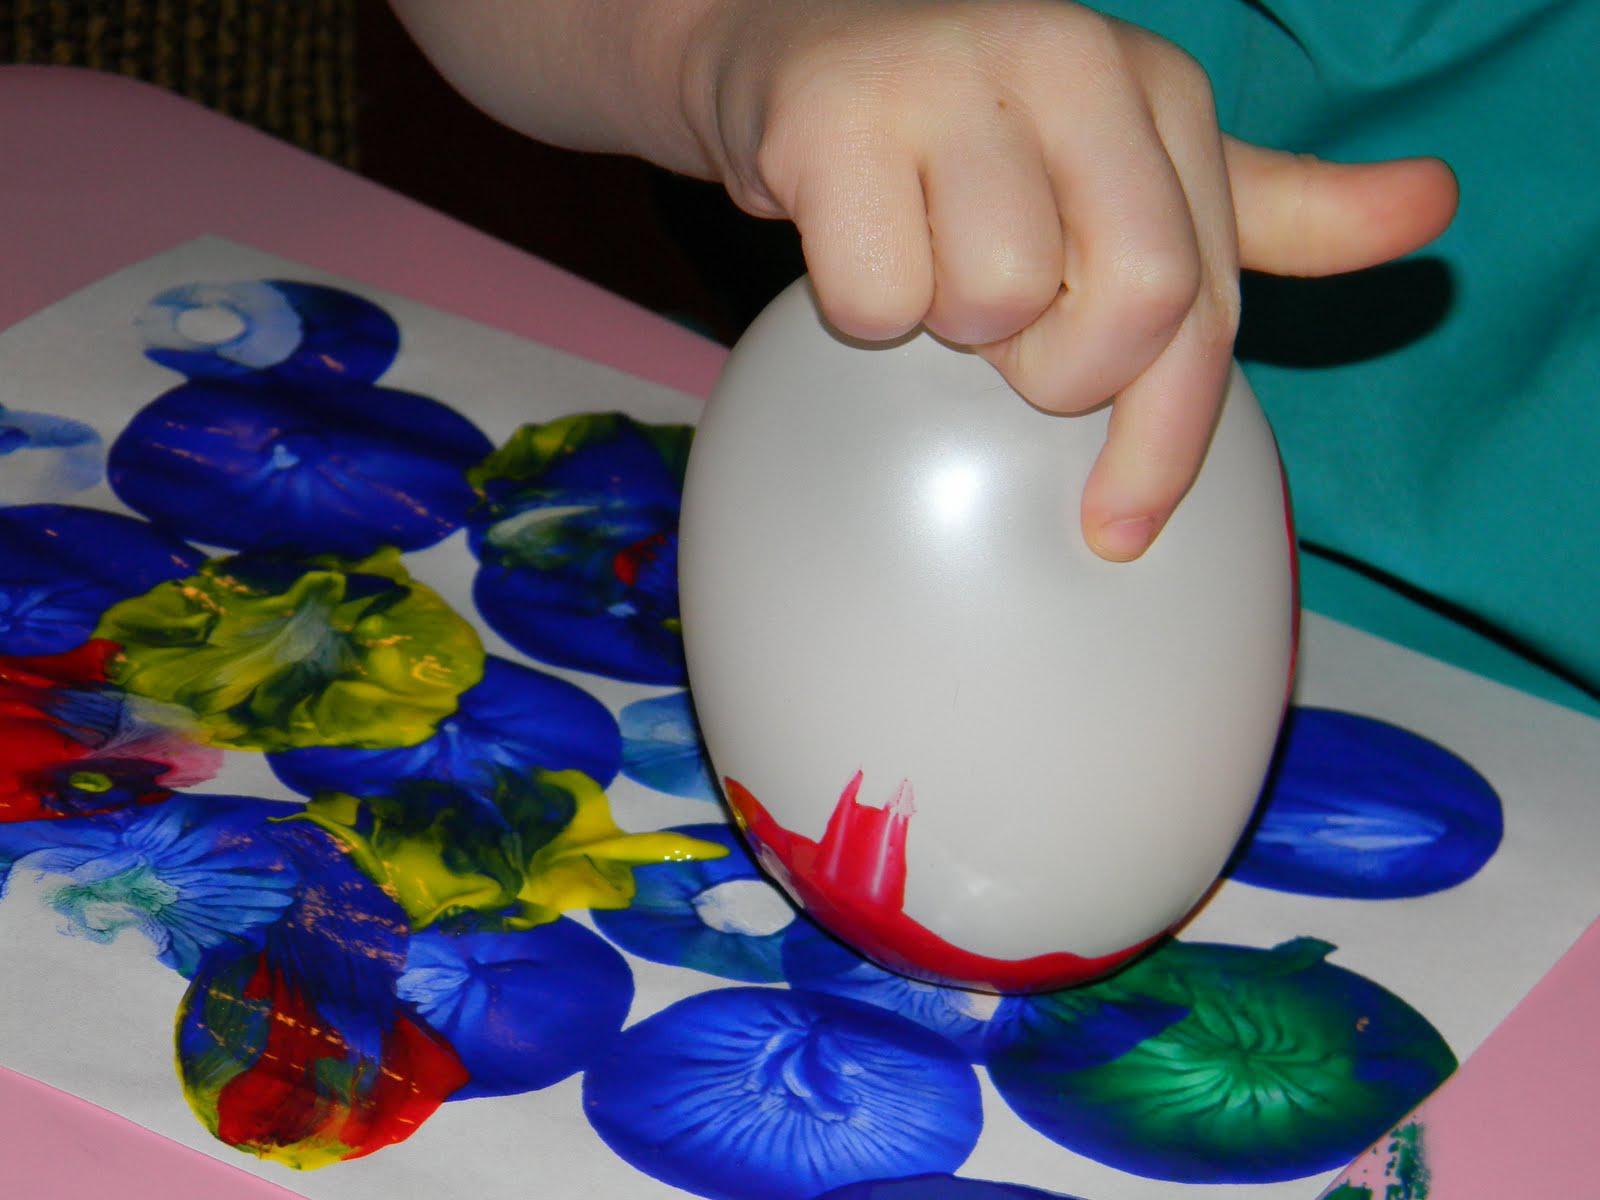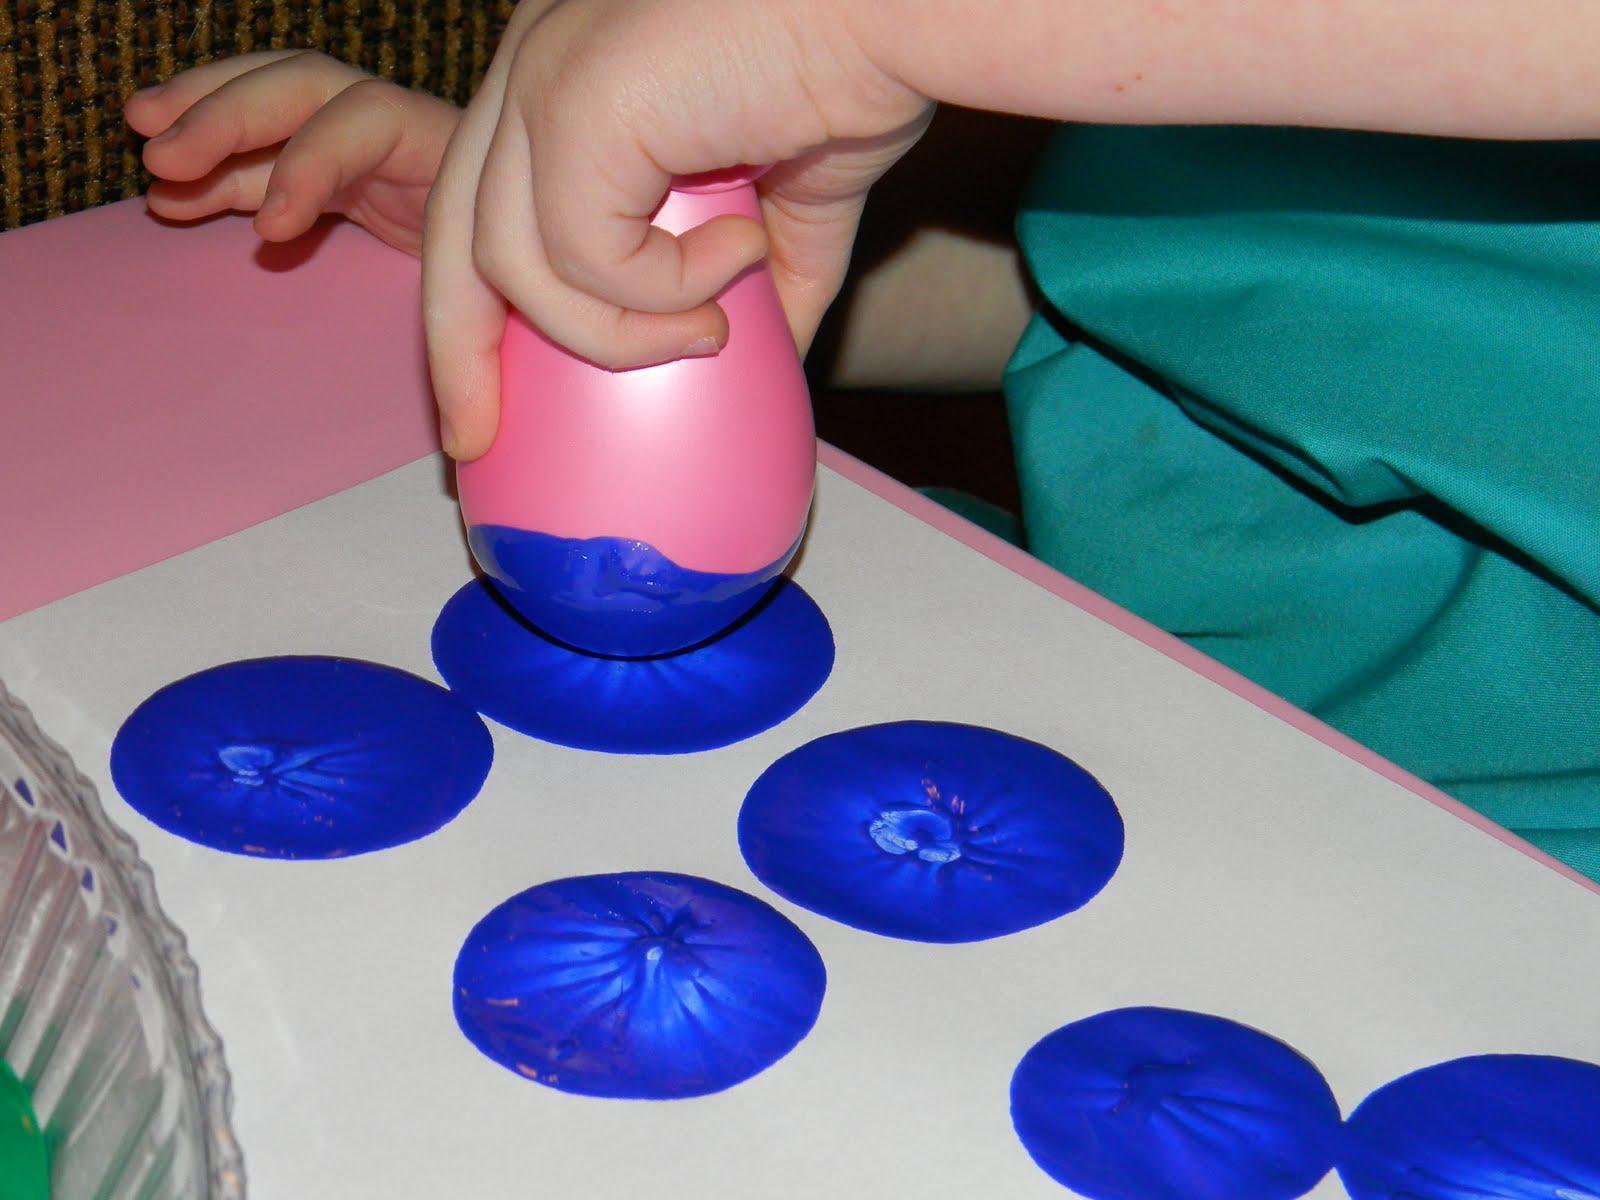The first image is the image on the left, the second image is the image on the right. For the images displayed, is the sentence "The left image contains at least two children." factually correct? Answer yes or no. No. The first image is the image on the left, the second image is the image on the right. For the images displayed, is the sentence "There are multiple children's heads visible." factually correct? Answer yes or no. No. 